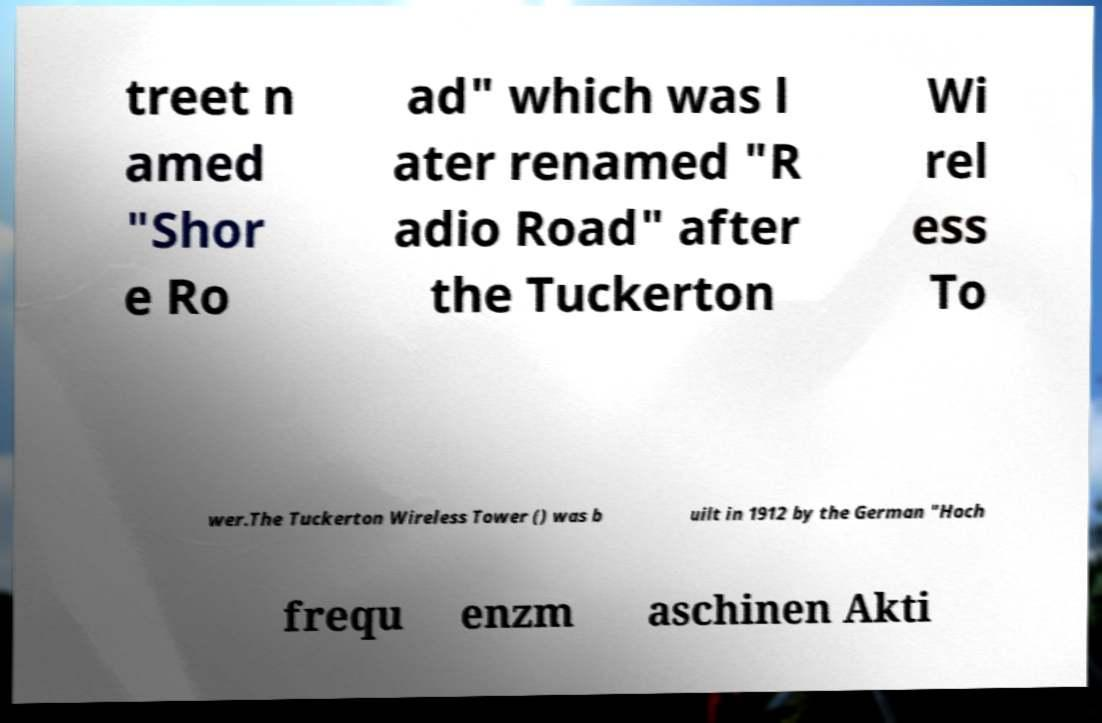There's text embedded in this image that I need extracted. Can you transcribe it verbatim? treet n amed "Shor e Ro ad" which was l ater renamed "R adio Road" after the Tuckerton Wi rel ess To wer.The Tuckerton Wireless Tower () was b uilt in 1912 by the German "Hoch frequ enzm aschinen Akti 